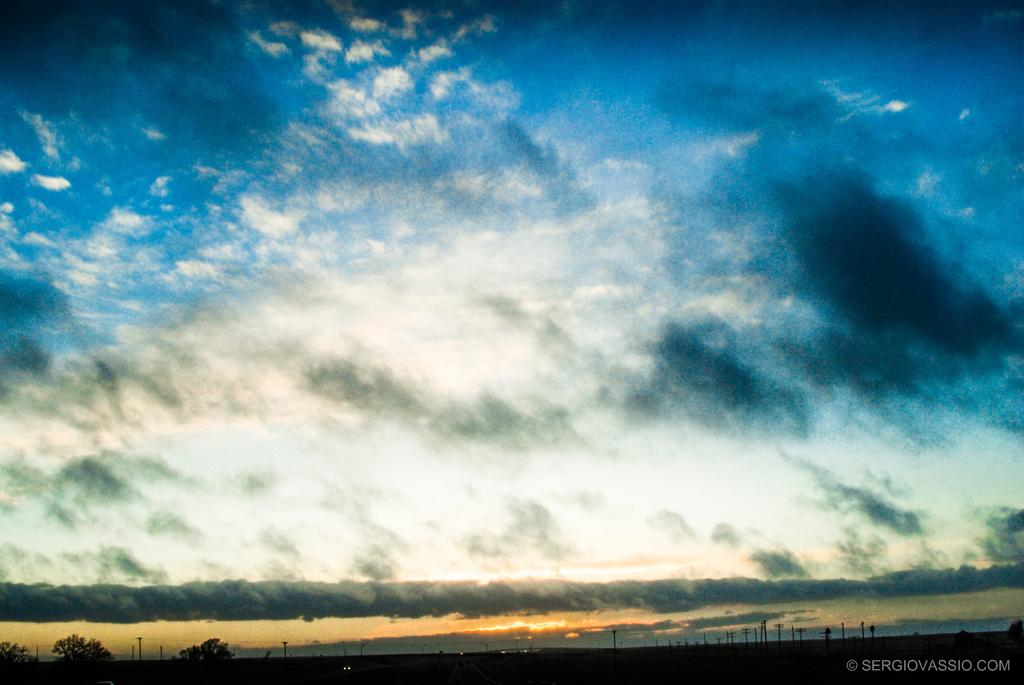Where was the image taken? The image was taken outdoors. What can be seen in the sky in the image? The sky with clouds is visible at the top of the image. What type of vegetation is present at the bottom of the image? There are trees on the ground at the bottom of the image. What structures can be seen in the image? There are a few poles in the image. Is there a scarecrow standing among the trees in the image? There is no scarecrow present in the image. What type of weather can be seen in the image? The image does not provide information about the weather; it only shows the sky with clouds. 